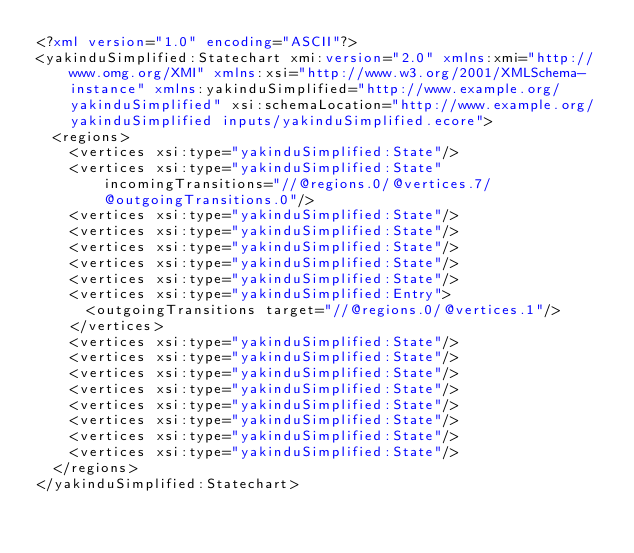<code> <loc_0><loc_0><loc_500><loc_500><_XML_><?xml version="1.0" encoding="ASCII"?>
<yakinduSimplified:Statechart xmi:version="2.0" xmlns:xmi="http://www.omg.org/XMI" xmlns:xsi="http://www.w3.org/2001/XMLSchema-instance" xmlns:yakinduSimplified="http://www.example.org/yakinduSimplified" xsi:schemaLocation="http://www.example.org/yakinduSimplified inputs/yakinduSimplified.ecore">
  <regions>
    <vertices xsi:type="yakinduSimplified:State"/>
    <vertices xsi:type="yakinduSimplified:State" incomingTransitions="//@regions.0/@vertices.7/@outgoingTransitions.0"/>
    <vertices xsi:type="yakinduSimplified:State"/>
    <vertices xsi:type="yakinduSimplified:State"/>
    <vertices xsi:type="yakinduSimplified:State"/>
    <vertices xsi:type="yakinduSimplified:State"/>
    <vertices xsi:type="yakinduSimplified:State"/>
    <vertices xsi:type="yakinduSimplified:Entry">
      <outgoingTransitions target="//@regions.0/@vertices.1"/>
    </vertices>
    <vertices xsi:type="yakinduSimplified:State"/>
    <vertices xsi:type="yakinduSimplified:State"/>
    <vertices xsi:type="yakinduSimplified:State"/>
    <vertices xsi:type="yakinduSimplified:State"/>
    <vertices xsi:type="yakinduSimplified:State"/>
    <vertices xsi:type="yakinduSimplified:State"/>
    <vertices xsi:type="yakinduSimplified:State"/>
    <vertices xsi:type="yakinduSimplified:State"/>
  </regions>
</yakinduSimplified:Statechart>
</code> 